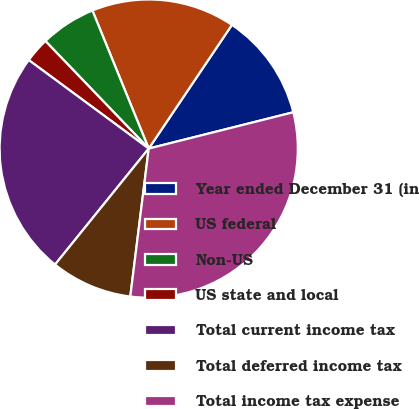<chart> <loc_0><loc_0><loc_500><loc_500><pie_chart><fcel>Year ended December 31 (in<fcel>US federal<fcel>Non-US<fcel>US state and local<fcel>Total current income tax<fcel>Total deferred income tax<fcel>Total income tax expense<nl><fcel>11.66%<fcel>15.59%<fcel>6.02%<fcel>2.7%<fcel>24.31%<fcel>8.84%<fcel>30.89%<nl></chart> 